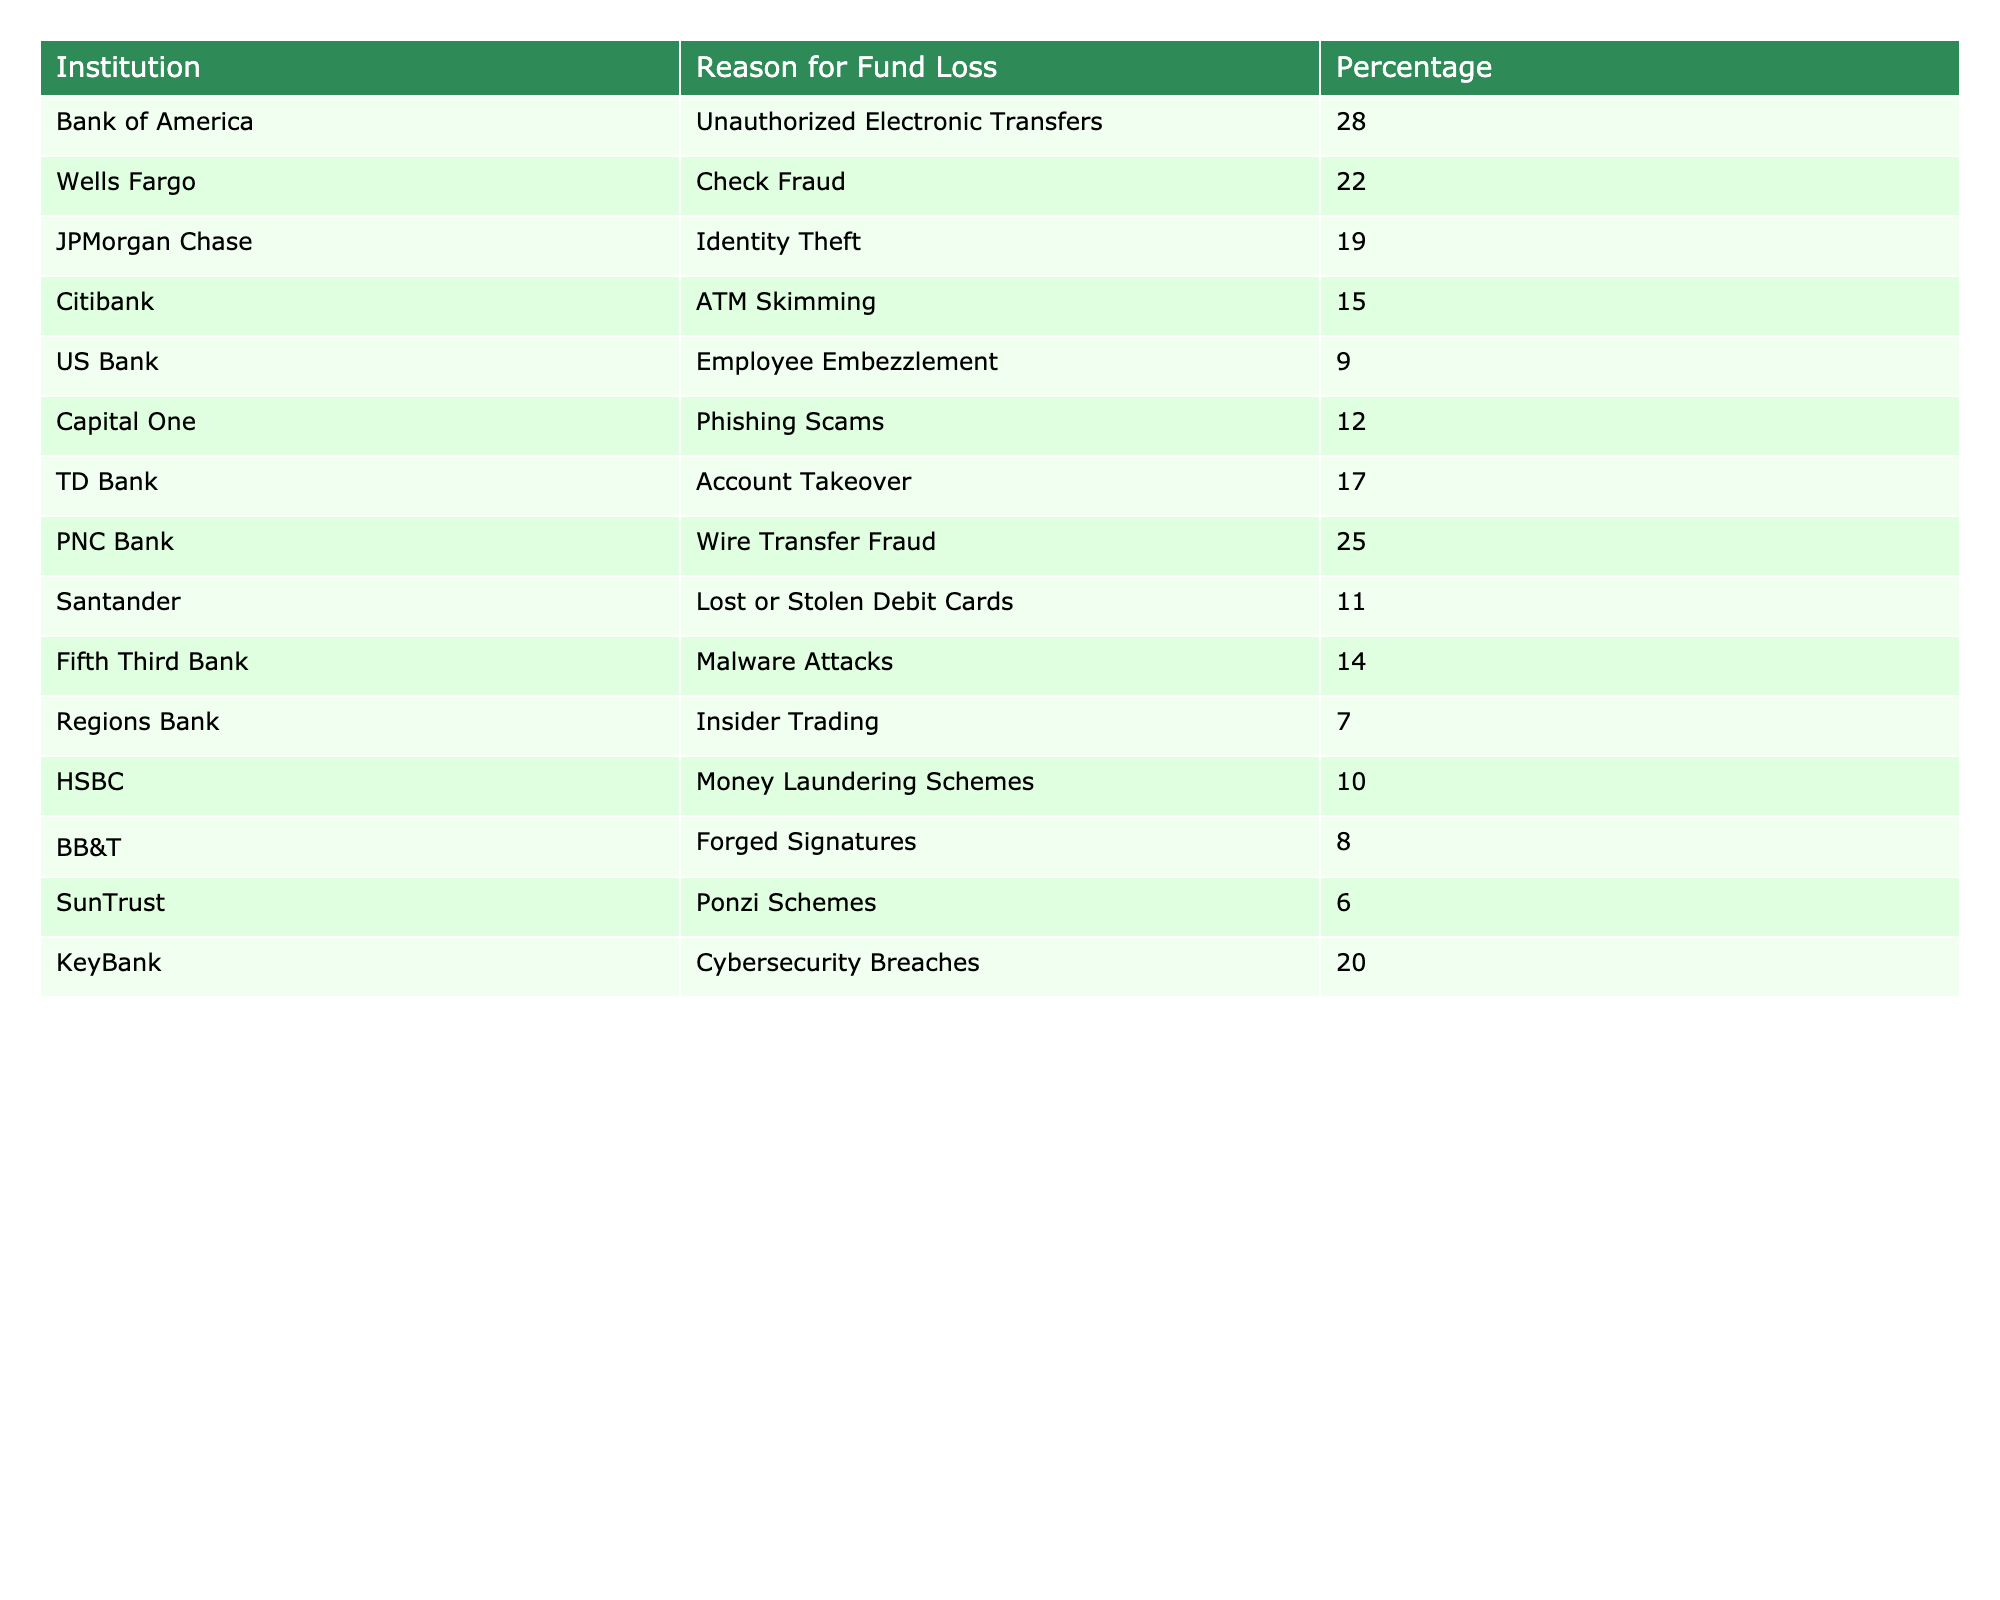What is the reason for fund loss with the highest percentage? By looking at the table, the row for Bank of America shows 'Unauthorized Electronic Transfers' with a percentage of 28, which is the highest among all the listed reasons.
Answer: Unauthorized Electronic Transfers Which institution has the lowest percentage of fund loss? The table shows 'SunTrust' with 'Ponzi Schemes' at 6%, which is the lowest percentage among the institutions listed.
Answer: SunTrust What is the total percentage of fund loss attributed to Identity Theft and Cybersecurity Breaches? The table lists 'Identity Theft' at 19% and 'Cybersecurity Breaches' at 20%. Adding these together, 19 + 20 results in a total of 39%.
Answer: 39% Are there any institutions associated with "Check Fraud"? Yes, the table mentions 'Wells Fargo' as having a percentage of 22% related to 'Check Fraud', confirming its presence in the data.
Answer: Yes Which reason for fund loss is associated with both a bank and a higher percentage than 20%? Looking at the table, 'Unauthorized Electronic Transfers' at 28% for Bank of America, and 'Wire Transfer Fraud' at 25% for PNC Bank both meet these criteria, answering the question positively.
Answer: Unauthorized Electronic Transfers and Wire Transfer Fraud What is the average percentage of fund loss for the reasons associated with Citibank and KeyBank? The table indicates 'ATM Skimming' for Citibank at 15% and 'Cybersecurity Breaches' for KeyBank at 20%. Calculating the average, (15 + 20) / 2 = 17.5%.
Answer: 17.5% Is there an institution with an associated percentage less than 10%? Yes, both 'Regions Bank' at 7% and 'BB&T' at 8% are listed, confirming that there are institutions with percentages below 10%.
Answer: Yes How many institutions report fund loss reasons that are related to scams or fraud? By reviewing the table, 'Phishing Scams', 'Wire Transfer Fraud', 'Check Fraud', and 'Ponzi Schemes' are all scams or fraud-related, totaling four institutions.
Answer: Four institutions What is the difference in percentage of fund loss between the highest and the lowest value? The highest percentage is 28% (Bank of America) and the lowest is 6% (SunTrust). The difference of 28 - 6 equals 22%.
Answer: 22% 